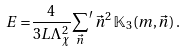Convert formula to latex. <formula><loc_0><loc_0><loc_500><loc_500>E = & \frac { 4 } { 3 L \Lambda _ { \chi } ^ { 2 } } { \sum _ { \vec { n } } } ^ { \prime } \, \vec { n } ^ { 2 } \, \mathbb { K } _ { 3 } ( m , \vec { n } ) \, .</formula> 